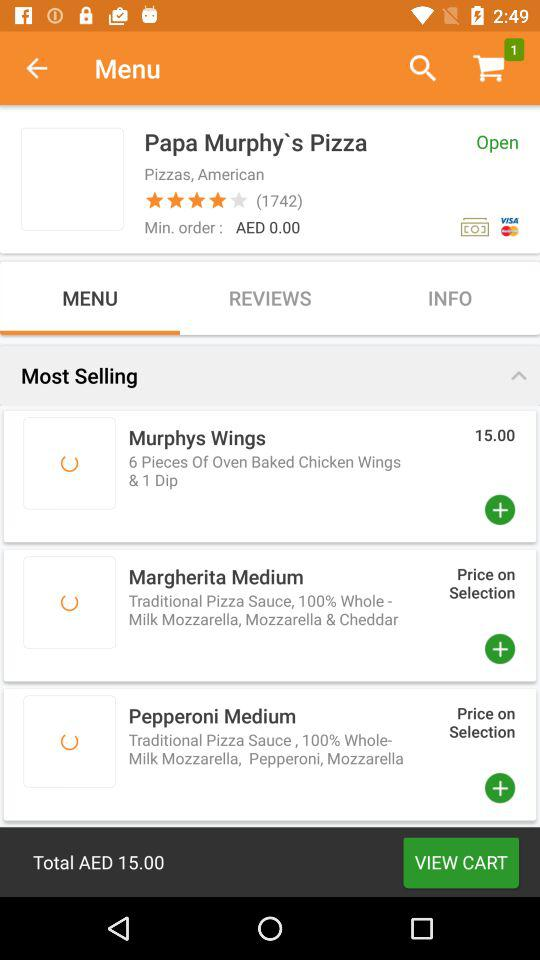What is the rating for "Papa Murphy's Pizza"? The rating for "Papa Murphy's Pizza" is 4 stars. 